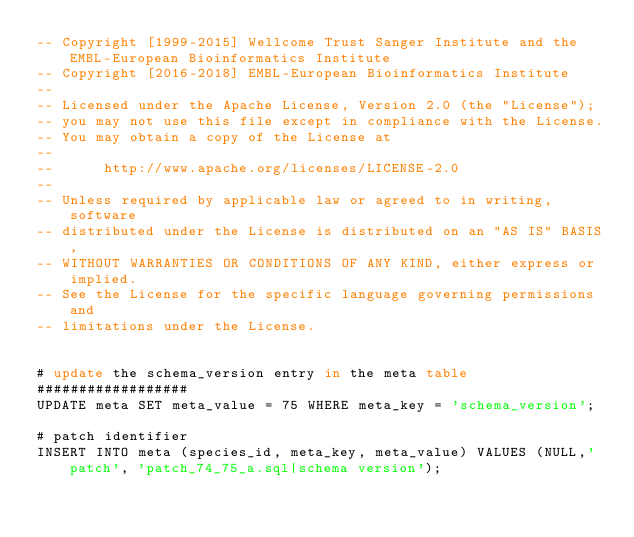<code> <loc_0><loc_0><loc_500><loc_500><_SQL_>-- Copyright [1999-2015] Wellcome Trust Sanger Institute and the EMBL-European Bioinformatics Institute
-- Copyright [2016-2018] EMBL-European Bioinformatics Institute
-- 
-- Licensed under the Apache License, Version 2.0 (the "License");
-- you may not use this file except in compliance with the License.
-- You may obtain a copy of the License at
-- 
--      http://www.apache.org/licenses/LICENSE-2.0
-- 
-- Unless required by applicable law or agreed to in writing, software
-- distributed under the License is distributed on an "AS IS" BASIS,
-- WITHOUT WARRANTIES OR CONDITIONS OF ANY KIND, either express or implied.
-- See the License for the specific language governing permissions and
-- limitations under the License.


# update the schema_version entry in the meta table
##################
UPDATE meta SET meta_value = 75 WHERE meta_key = 'schema_version';

# patch identifier
INSERT INTO meta (species_id, meta_key, meta_value) VALUES (NULL,'patch', 'patch_74_75_a.sql|schema version');
</code> 